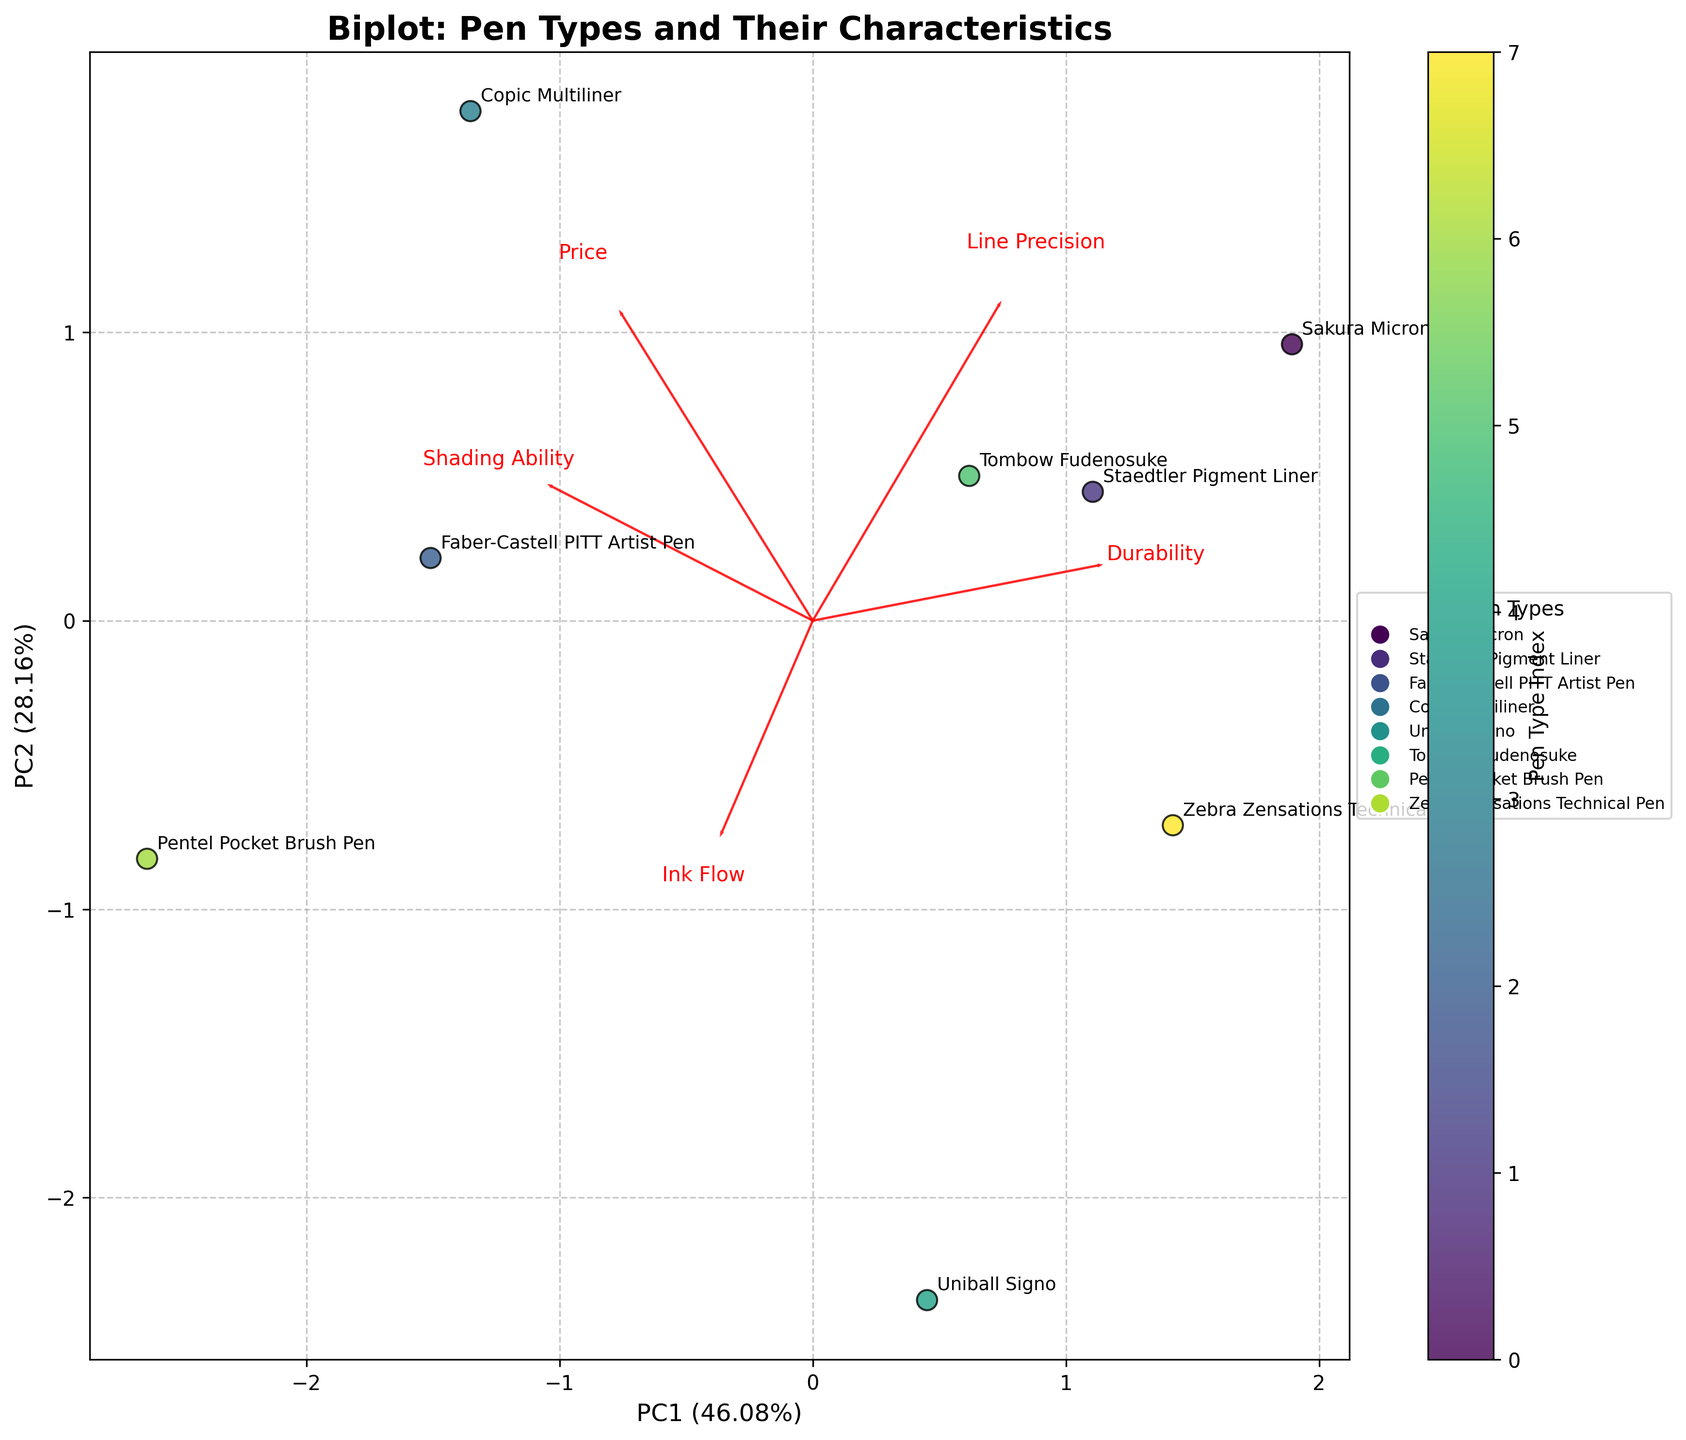What's the title of the plot? The title is displayed at the top of the plot in larger, bold font. It summarizes what the plot is about.
Answer: Biplot: Pen Types and Their Characteristics Which pen type has the highest PC1 value? To determine which pen type has the highest PC1 value, look at the x-axis (PC1) and identify the point farthest to the right.
Answer: Sakura Micron How many pen types are represented in the plot? Count the unique pen type labels annotated on the points in the plot.
Answer: 8 Which feature has the highest weight in PC2? Look at the red arrows representing features. The feature with the most significant y-direction component (PC2 axis) has the highest weight in PC2.
Answer: Shading Ability Which pen types are closest to each other in the plot? Find the pen types that are positioned closest together according to their coordinates on the plot.
Answer: Staedtler Pigment Liner and Zebra Zensations Technical Pen Which feature affects both PC1 and PC2 equally? Identify the feature whose red arrow is roughly at a 45-degree angle from both PC1 and PC2 axes.
Answer: Ink Flow What percentage of variance does PC1 explain? Look at the x-axis label for the percentage of variance explained by PC1.
Answer: 42.5% Compare the durability of Sakura Micron and Faber-Castell PITT Artist Pen. Which is more durable? Check the positions of Sakura Micron and Faber-Castell PITT Artist Pen along the direction of the 'Durability' arrow. The one closer to the arrow tip is more durable.
Answer: Sakura Micron Which pen type is the least precise according to the plot? Look along the direction of the 'Line Precision' arrow; the pen farthest in the opposite direction is the least precise.
Answer: Pentel Pocket Brush Pen What's the relationship between shading ability and line precision for Tombow Fudenosuke? Observe Tombow Fudenosuke's position relative to 'Shading Ability' and 'Line Precision' arrows. Both vectors should be considered.
Answer: High shading ability and moderate line precision 